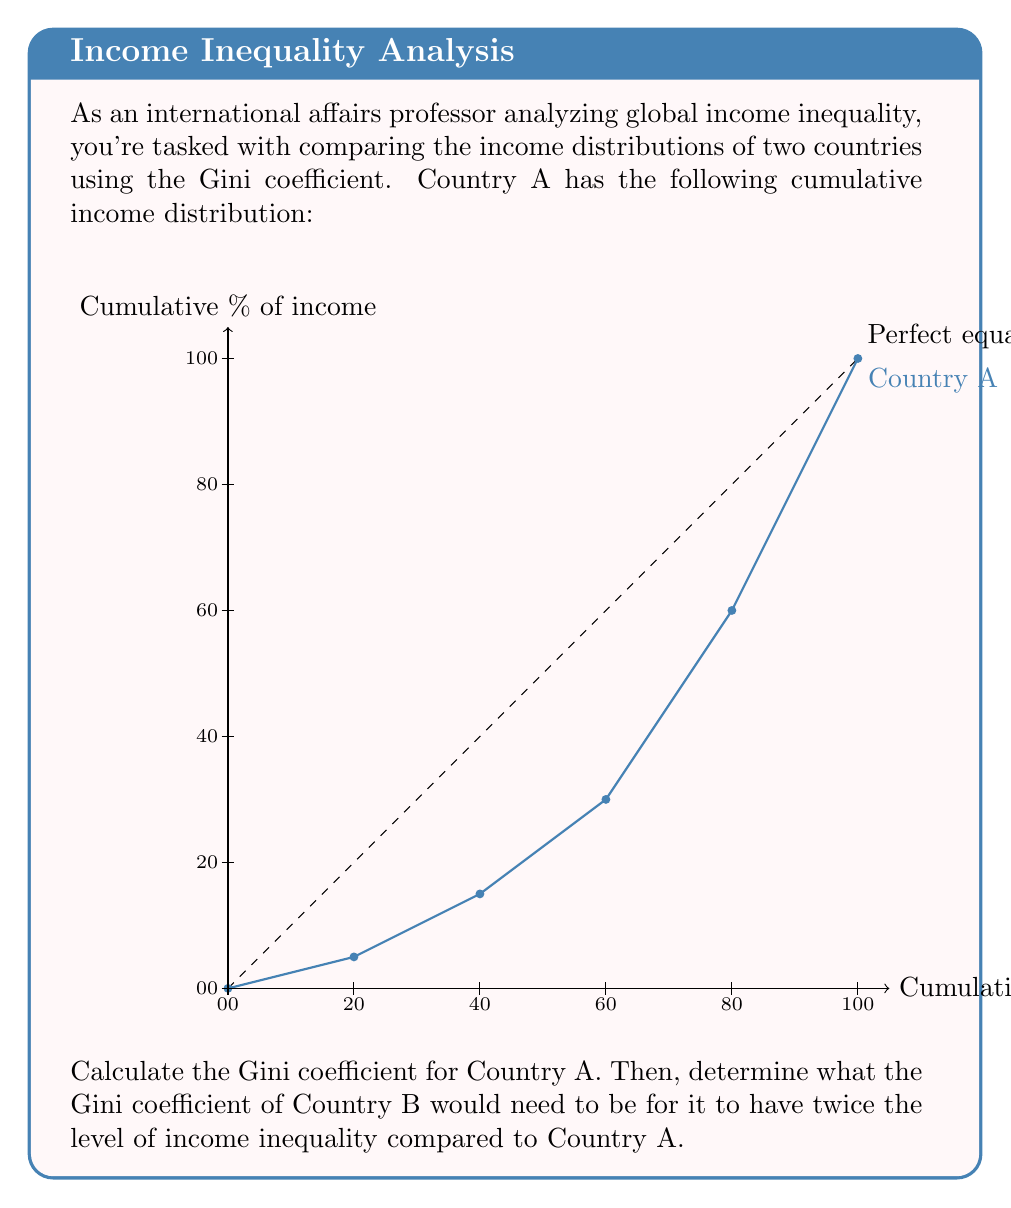What is the answer to this math problem? To solve this problem, we'll follow these steps:

1) Calculate the Gini coefficient for Country A:
   The Gini coefficient is defined as the ratio of the area between the line of perfect equality and the Lorenz curve to the total area under the line of perfect equality.

   a) Calculate the area under the line of perfect equality:
      This is always 0.5 (or 5000 in our scale).

   b) Calculate the area under the Lorenz curve using the trapezoidal rule:
      Area = $\frac{1}{2} \sum_{i=1}^{n} (x_i - x_{i-1})(y_i + y_{i-1})$
      
      $= \frac{1}{2}[(20-0)(5+0) + (40-20)(15+5) + (60-40)(30+15) + (80-60)(60+30) + (100-80)(100+60)]$
      $= \frac{1}{2}[100 + 400 + 900 + 1800 + 3200]$
      $= \frac{1}{2}[6400] = 3200$

   c) Calculate the area between the line of perfect equality and the Lorenz curve:
      5000 - 3200 = 1800

   d) Calculate the Gini coefficient:
      Gini = $\frac{1800}{5000} = 0.36$

2) For Country B to have twice the level of income inequality:
   Let x be the Gini coefficient of Country B.
   We want: $\frac{x}{0.36} = 2$
   Solving for x: $x = 2 * 0.36 = 0.72$

Therefore, the Gini coefficient of Country B would need to be 0.72 to have twice the level of income inequality compared to Country A.
Answer: 0.72 